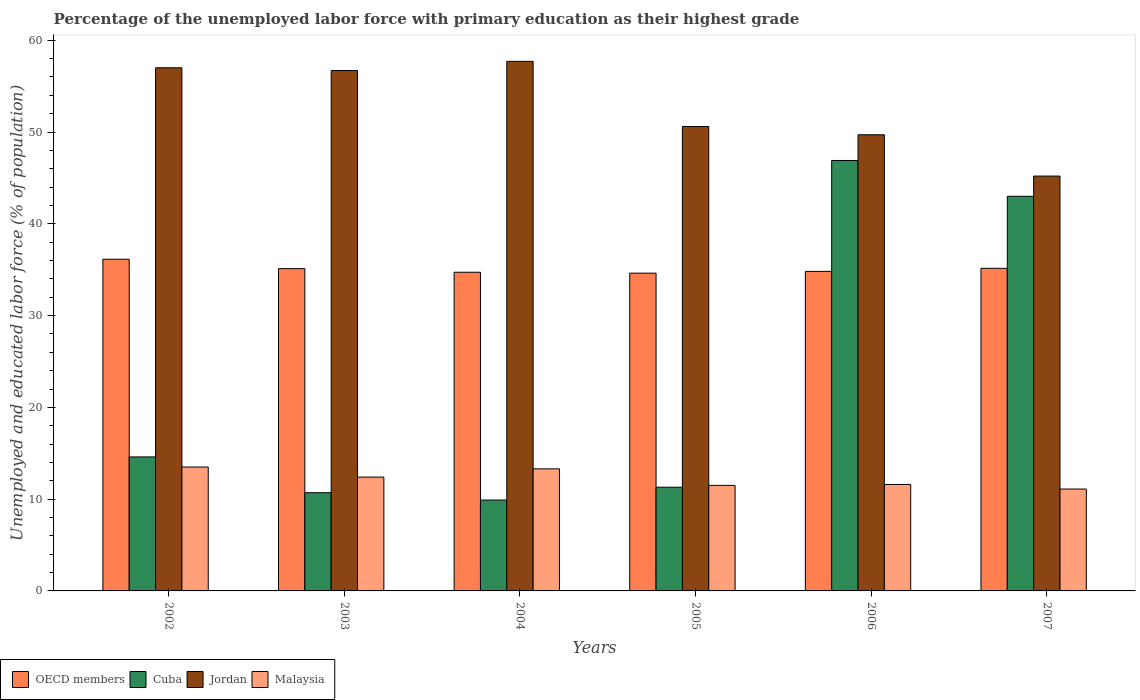How many different coloured bars are there?
Your response must be concise. 4. How many bars are there on the 6th tick from the right?
Make the answer very short. 4. What is the label of the 6th group of bars from the left?
Your answer should be very brief. 2007. What is the percentage of the unemployed labor force with primary education in Malaysia in 2006?
Your response must be concise. 11.6. Across all years, what is the maximum percentage of the unemployed labor force with primary education in OECD members?
Offer a terse response. 36.14. Across all years, what is the minimum percentage of the unemployed labor force with primary education in Jordan?
Ensure brevity in your answer.  45.2. In which year was the percentage of the unemployed labor force with primary education in Malaysia maximum?
Your answer should be very brief. 2002. What is the total percentage of the unemployed labor force with primary education in OECD members in the graph?
Offer a terse response. 210.56. What is the difference between the percentage of the unemployed labor force with primary education in Jordan in 2002 and that in 2003?
Keep it short and to the point. 0.3. What is the difference between the percentage of the unemployed labor force with primary education in Malaysia in 2007 and the percentage of the unemployed labor force with primary education in Jordan in 2004?
Provide a succinct answer. -46.6. What is the average percentage of the unemployed labor force with primary education in Malaysia per year?
Your answer should be very brief. 12.23. In the year 2003, what is the difference between the percentage of the unemployed labor force with primary education in OECD members and percentage of the unemployed labor force with primary education in Cuba?
Ensure brevity in your answer.  24.41. In how many years, is the percentage of the unemployed labor force with primary education in Cuba greater than 42 %?
Your answer should be very brief. 2. What is the ratio of the percentage of the unemployed labor force with primary education in OECD members in 2004 to that in 2007?
Keep it short and to the point. 0.99. Is the percentage of the unemployed labor force with primary education in OECD members in 2004 less than that in 2007?
Your response must be concise. Yes. Is the difference between the percentage of the unemployed labor force with primary education in OECD members in 2003 and 2005 greater than the difference between the percentage of the unemployed labor force with primary education in Cuba in 2003 and 2005?
Your response must be concise. Yes. What is the difference between the highest and the second highest percentage of the unemployed labor force with primary education in OECD members?
Offer a very short reply. 0.99. What is the difference between the highest and the lowest percentage of the unemployed labor force with primary education in Jordan?
Your response must be concise. 12.5. In how many years, is the percentage of the unemployed labor force with primary education in Jordan greater than the average percentage of the unemployed labor force with primary education in Jordan taken over all years?
Provide a succinct answer. 3. Is the sum of the percentage of the unemployed labor force with primary education in OECD members in 2002 and 2003 greater than the maximum percentage of the unemployed labor force with primary education in Jordan across all years?
Make the answer very short. Yes. Is it the case that in every year, the sum of the percentage of the unemployed labor force with primary education in Jordan and percentage of the unemployed labor force with primary education in Cuba is greater than the sum of percentage of the unemployed labor force with primary education in Malaysia and percentage of the unemployed labor force with primary education in OECD members?
Provide a succinct answer. Yes. What does the 1st bar from the right in 2005 represents?
Make the answer very short. Malaysia. Is it the case that in every year, the sum of the percentage of the unemployed labor force with primary education in Cuba and percentage of the unemployed labor force with primary education in Malaysia is greater than the percentage of the unemployed labor force with primary education in OECD members?
Your response must be concise. No. How many bars are there?
Your response must be concise. 24. Are all the bars in the graph horizontal?
Provide a short and direct response. No. What is the difference between two consecutive major ticks on the Y-axis?
Your answer should be compact. 10. Does the graph contain grids?
Offer a very short reply. No. What is the title of the graph?
Offer a very short reply. Percentage of the unemployed labor force with primary education as their highest grade. Does "Malaysia" appear as one of the legend labels in the graph?
Provide a succinct answer. Yes. What is the label or title of the Y-axis?
Make the answer very short. Unemployed and educated labor force (% of population). What is the Unemployed and educated labor force (% of population) of OECD members in 2002?
Give a very brief answer. 36.14. What is the Unemployed and educated labor force (% of population) in Cuba in 2002?
Provide a succinct answer. 14.6. What is the Unemployed and educated labor force (% of population) of Jordan in 2002?
Ensure brevity in your answer.  57. What is the Unemployed and educated labor force (% of population) in OECD members in 2003?
Your answer should be compact. 35.11. What is the Unemployed and educated labor force (% of population) of Cuba in 2003?
Your response must be concise. 10.7. What is the Unemployed and educated labor force (% of population) of Jordan in 2003?
Ensure brevity in your answer.  56.7. What is the Unemployed and educated labor force (% of population) in Malaysia in 2003?
Offer a terse response. 12.4. What is the Unemployed and educated labor force (% of population) in OECD members in 2004?
Give a very brief answer. 34.72. What is the Unemployed and educated labor force (% of population) in Cuba in 2004?
Ensure brevity in your answer.  9.9. What is the Unemployed and educated labor force (% of population) of Jordan in 2004?
Keep it short and to the point. 57.7. What is the Unemployed and educated labor force (% of population) in Malaysia in 2004?
Your answer should be very brief. 13.3. What is the Unemployed and educated labor force (% of population) of OECD members in 2005?
Your response must be concise. 34.62. What is the Unemployed and educated labor force (% of population) of Cuba in 2005?
Provide a short and direct response. 11.3. What is the Unemployed and educated labor force (% of population) of Jordan in 2005?
Make the answer very short. 50.6. What is the Unemployed and educated labor force (% of population) in Malaysia in 2005?
Provide a short and direct response. 11.5. What is the Unemployed and educated labor force (% of population) of OECD members in 2006?
Provide a short and direct response. 34.81. What is the Unemployed and educated labor force (% of population) in Cuba in 2006?
Ensure brevity in your answer.  46.9. What is the Unemployed and educated labor force (% of population) in Jordan in 2006?
Your answer should be compact. 49.7. What is the Unemployed and educated labor force (% of population) in Malaysia in 2006?
Your response must be concise. 11.6. What is the Unemployed and educated labor force (% of population) of OECD members in 2007?
Keep it short and to the point. 35.15. What is the Unemployed and educated labor force (% of population) of Cuba in 2007?
Offer a very short reply. 43. What is the Unemployed and educated labor force (% of population) in Jordan in 2007?
Offer a terse response. 45.2. What is the Unemployed and educated labor force (% of population) in Malaysia in 2007?
Your response must be concise. 11.1. Across all years, what is the maximum Unemployed and educated labor force (% of population) in OECD members?
Your answer should be very brief. 36.14. Across all years, what is the maximum Unemployed and educated labor force (% of population) of Cuba?
Ensure brevity in your answer.  46.9. Across all years, what is the maximum Unemployed and educated labor force (% of population) of Jordan?
Your response must be concise. 57.7. Across all years, what is the minimum Unemployed and educated labor force (% of population) of OECD members?
Offer a terse response. 34.62. Across all years, what is the minimum Unemployed and educated labor force (% of population) of Cuba?
Offer a very short reply. 9.9. Across all years, what is the minimum Unemployed and educated labor force (% of population) in Jordan?
Give a very brief answer. 45.2. Across all years, what is the minimum Unemployed and educated labor force (% of population) of Malaysia?
Give a very brief answer. 11.1. What is the total Unemployed and educated labor force (% of population) of OECD members in the graph?
Offer a very short reply. 210.56. What is the total Unemployed and educated labor force (% of population) in Cuba in the graph?
Ensure brevity in your answer.  136.4. What is the total Unemployed and educated labor force (% of population) of Jordan in the graph?
Ensure brevity in your answer.  316.9. What is the total Unemployed and educated labor force (% of population) of Malaysia in the graph?
Ensure brevity in your answer.  73.4. What is the difference between the Unemployed and educated labor force (% of population) in OECD members in 2002 and that in 2003?
Give a very brief answer. 1.03. What is the difference between the Unemployed and educated labor force (% of population) in Jordan in 2002 and that in 2003?
Keep it short and to the point. 0.3. What is the difference between the Unemployed and educated labor force (% of population) in Malaysia in 2002 and that in 2003?
Your answer should be compact. 1.1. What is the difference between the Unemployed and educated labor force (% of population) in OECD members in 2002 and that in 2004?
Your response must be concise. 1.42. What is the difference between the Unemployed and educated labor force (% of population) of Cuba in 2002 and that in 2004?
Your answer should be compact. 4.7. What is the difference between the Unemployed and educated labor force (% of population) in OECD members in 2002 and that in 2005?
Provide a short and direct response. 1.52. What is the difference between the Unemployed and educated labor force (% of population) in Cuba in 2002 and that in 2005?
Offer a terse response. 3.3. What is the difference between the Unemployed and educated labor force (% of population) of Jordan in 2002 and that in 2005?
Offer a terse response. 6.4. What is the difference between the Unemployed and educated labor force (% of population) in Malaysia in 2002 and that in 2005?
Ensure brevity in your answer.  2. What is the difference between the Unemployed and educated labor force (% of population) in OECD members in 2002 and that in 2006?
Offer a terse response. 1.33. What is the difference between the Unemployed and educated labor force (% of population) of Cuba in 2002 and that in 2006?
Offer a very short reply. -32.3. What is the difference between the Unemployed and educated labor force (% of population) in OECD members in 2002 and that in 2007?
Your answer should be compact. 0.99. What is the difference between the Unemployed and educated labor force (% of population) in Cuba in 2002 and that in 2007?
Keep it short and to the point. -28.4. What is the difference between the Unemployed and educated labor force (% of population) in OECD members in 2003 and that in 2004?
Keep it short and to the point. 0.39. What is the difference between the Unemployed and educated labor force (% of population) in Jordan in 2003 and that in 2004?
Keep it short and to the point. -1. What is the difference between the Unemployed and educated labor force (% of population) of Malaysia in 2003 and that in 2004?
Offer a terse response. -0.9. What is the difference between the Unemployed and educated labor force (% of population) of OECD members in 2003 and that in 2005?
Provide a short and direct response. 0.49. What is the difference between the Unemployed and educated labor force (% of population) in Jordan in 2003 and that in 2005?
Ensure brevity in your answer.  6.1. What is the difference between the Unemployed and educated labor force (% of population) of OECD members in 2003 and that in 2006?
Your response must be concise. 0.3. What is the difference between the Unemployed and educated labor force (% of population) in Cuba in 2003 and that in 2006?
Ensure brevity in your answer.  -36.2. What is the difference between the Unemployed and educated labor force (% of population) of Jordan in 2003 and that in 2006?
Your answer should be compact. 7. What is the difference between the Unemployed and educated labor force (% of population) of Malaysia in 2003 and that in 2006?
Offer a very short reply. 0.8. What is the difference between the Unemployed and educated labor force (% of population) in OECD members in 2003 and that in 2007?
Make the answer very short. -0.04. What is the difference between the Unemployed and educated labor force (% of population) in Cuba in 2003 and that in 2007?
Provide a short and direct response. -32.3. What is the difference between the Unemployed and educated labor force (% of population) of Jordan in 2003 and that in 2007?
Keep it short and to the point. 11.5. What is the difference between the Unemployed and educated labor force (% of population) of Malaysia in 2003 and that in 2007?
Keep it short and to the point. 1.3. What is the difference between the Unemployed and educated labor force (% of population) in OECD members in 2004 and that in 2005?
Your answer should be compact. 0.1. What is the difference between the Unemployed and educated labor force (% of population) of Jordan in 2004 and that in 2005?
Make the answer very short. 7.1. What is the difference between the Unemployed and educated labor force (% of population) of OECD members in 2004 and that in 2006?
Your answer should be compact. -0.09. What is the difference between the Unemployed and educated labor force (% of population) of Cuba in 2004 and that in 2006?
Your answer should be very brief. -37. What is the difference between the Unemployed and educated labor force (% of population) in Malaysia in 2004 and that in 2006?
Make the answer very short. 1.7. What is the difference between the Unemployed and educated labor force (% of population) of OECD members in 2004 and that in 2007?
Offer a very short reply. -0.43. What is the difference between the Unemployed and educated labor force (% of population) of Cuba in 2004 and that in 2007?
Offer a very short reply. -33.1. What is the difference between the Unemployed and educated labor force (% of population) in Jordan in 2004 and that in 2007?
Ensure brevity in your answer.  12.5. What is the difference between the Unemployed and educated labor force (% of population) in OECD members in 2005 and that in 2006?
Offer a very short reply. -0.19. What is the difference between the Unemployed and educated labor force (% of population) of Cuba in 2005 and that in 2006?
Ensure brevity in your answer.  -35.6. What is the difference between the Unemployed and educated labor force (% of population) in Jordan in 2005 and that in 2006?
Provide a succinct answer. 0.9. What is the difference between the Unemployed and educated labor force (% of population) of OECD members in 2005 and that in 2007?
Provide a succinct answer. -0.53. What is the difference between the Unemployed and educated labor force (% of population) in Cuba in 2005 and that in 2007?
Give a very brief answer. -31.7. What is the difference between the Unemployed and educated labor force (% of population) in Malaysia in 2005 and that in 2007?
Ensure brevity in your answer.  0.4. What is the difference between the Unemployed and educated labor force (% of population) of OECD members in 2006 and that in 2007?
Your response must be concise. -0.34. What is the difference between the Unemployed and educated labor force (% of population) of Cuba in 2006 and that in 2007?
Offer a terse response. 3.9. What is the difference between the Unemployed and educated labor force (% of population) of OECD members in 2002 and the Unemployed and educated labor force (% of population) of Cuba in 2003?
Provide a succinct answer. 25.44. What is the difference between the Unemployed and educated labor force (% of population) in OECD members in 2002 and the Unemployed and educated labor force (% of population) in Jordan in 2003?
Ensure brevity in your answer.  -20.56. What is the difference between the Unemployed and educated labor force (% of population) in OECD members in 2002 and the Unemployed and educated labor force (% of population) in Malaysia in 2003?
Make the answer very short. 23.74. What is the difference between the Unemployed and educated labor force (% of population) of Cuba in 2002 and the Unemployed and educated labor force (% of population) of Jordan in 2003?
Your response must be concise. -42.1. What is the difference between the Unemployed and educated labor force (% of population) in Jordan in 2002 and the Unemployed and educated labor force (% of population) in Malaysia in 2003?
Keep it short and to the point. 44.6. What is the difference between the Unemployed and educated labor force (% of population) in OECD members in 2002 and the Unemployed and educated labor force (% of population) in Cuba in 2004?
Ensure brevity in your answer.  26.24. What is the difference between the Unemployed and educated labor force (% of population) in OECD members in 2002 and the Unemployed and educated labor force (% of population) in Jordan in 2004?
Ensure brevity in your answer.  -21.56. What is the difference between the Unemployed and educated labor force (% of population) in OECD members in 2002 and the Unemployed and educated labor force (% of population) in Malaysia in 2004?
Provide a short and direct response. 22.84. What is the difference between the Unemployed and educated labor force (% of population) in Cuba in 2002 and the Unemployed and educated labor force (% of population) in Jordan in 2004?
Offer a very short reply. -43.1. What is the difference between the Unemployed and educated labor force (% of population) of Jordan in 2002 and the Unemployed and educated labor force (% of population) of Malaysia in 2004?
Offer a very short reply. 43.7. What is the difference between the Unemployed and educated labor force (% of population) of OECD members in 2002 and the Unemployed and educated labor force (% of population) of Cuba in 2005?
Offer a very short reply. 24.84. What is the difference between the Unemployed and educated labor force (% of population) in OECD members in 2002 and the Unemployed and educated labor force (% of population) in Jordan in 2005?
Provide a short and direct response. -14.46. What is the difference between the Unemployed and educated labor force (% of population) of OECD members in 2002 and the Unemployed and educated labor force (% of population) of Malaysia in 2005?
Give a very brief answer. 24.64. What is the difference between the Unemployed and educated labor force (% of population) in Cuba in 2002 and the Unemployed and educated labor force (% of population) in Jordan in 2005?
Your response must be concise. -36. What is the difference between the Unemployed and educated labor force (% of population) in Jordan in 2002 and the Unemployed and educated labor force (% of population) in Malaysia in 2005?
Ensure brevity in your answer.  45.5. What is the difference between the Unemployed and educated labor force (% of population) in OECD members in 2002 and the Unemployed and educated labor force (% of population) in Cuba in 2006?
Keep it short and to the point. -10.76. What is the difference between the Unemployed and educated labor force (% of population) of OECD members in 2002 and the Unemployed and educated labor force (% of population) of Jordan in 2006?
Your response must be concise. -13.56. What is the difference between the Unemployed and educated labor force (% of population) of OECD members in 2002 and the Unemployed and educated labor force (% of population) of Malaysia in 2006?
Make the answer very short. 24.54. What is the difference between the Unemployed and educated labor force (% of population) of Cuba in 2002 and the Unemployed and educated labor force (% of population) of Jordan in 2006?
Ensure brevity in your answer.  -35.1. What is the difference between the Unemployed and educated labor force (% of population) of Jordan in 2002 and the Unemployed and educated labor force (% of population) of Malaysia in 2006?
Ensure brevity in your answer.  45.4. What is the difference between the Unemployed and educated labor force (% of population) in OECD members in 2002 and the Unemployed and educated labor force (% of population) in Cuba in 2007?
Your answer should be compact. -6.86. What is the difference between the Unemployed and educated labor force (% of population) of OECD members in 2002 and the Unemployed and educated labor force (% of population) of Jordan in 2007?
Provide a succinct answer. -9.06. What is the difference between the Unemployed and educated labor force (% of population) of OECD members in 2002 and the Unemployed and educated labor force (% of population) of Malaysia in 2007?
Offer a terse response. 25.04. What is the difference between the Unemployed and educated labor force (% of population) of Cuba in 2002 and the Unemployed and educated labor force (% of population) of Jordan in 2007?
Offer a very short reply. -30.6. What is the difference between the Unemployed and educated labor force (% of population) in Cuba in 2002 and the Unemployed and educated labor force (% of population) in Malaysia in 2007?
Your response must be concise. 3.5. What is the difference between the Unemployed and educated labor force (% of population) in Jordan in 2002 and the Unemployed and educated labor force (% of population) in Malaysia in 2007?
Keep it short and to the point. 45.9. What is the difference between the Unemployed and educated labor force (% of population) of OECD members in 2003 and the Unemployed and educated labor force (% of population) of Cuba in 2004?
Your answer should be compact. 25.21. What is the difference between the Unemployed and educated labor force (% of population) in OECD members in 2003 and the Unemployed and educated labor force (% of population) in Jordan in 2004?
Your response must be concise. -22.59. What is the difference between the Unemployed and educated labor force (% of population) of OECD members in 2003 and the Unemployed and educated labor force (% of population) of Malaysia in 2004?
Offer a very short reply. 21.81. What is the difference between the Unemployed and educated labor force (% of population) in Cuba in 2003 and the Unemployed and educated labor force (% of population) in Jordan in 2004?
Ensure brevity in your answer.  -47. What is the difference between the Unemployed and educated labor force (% of population) in Jordan in 2003 and the Unemployed and educated labor force (% of population) in Malaysia in 2004?
Your response must be concise. 43.4. What is the difference between the Unemployed and educated labor force (% of population) in OECD members in 2003 and the Unemployed and educated labor force (% of population) in Cuba in 2005?
Make the answer very short. 23.81. What is the difference between the Unemployed and educated labor force (% of population) in OECD members in 2003 and the Unemployed and educated labor force (% of population) in Jordan in 2005?
Provide a succinct answer. -15.49. What is the difference between the Unemployed and educated labor force (% of population) in OECD members in 2003 and the Unemployed and educated labor force (% of population) in Malaysia in 2005?
Your answer should be very brief. 23.61. What is the difference between the Unemployed and educated labor force (% of population) in Cuba in 2003 and the Unemployed and educated labor force (% of population) in Jordan in 2005?
Ensure brevity in your answer.  -39.9. What is the difference between the Unemployed and educated labor force (% of population) of Jordan in 2003 and the Unemployed and educated labor force (% of population) of Malaysia in 2005?
Give a very brief answer. 45.2. What is the difference between the Unemployed and educated labor force (% of population) of OECD members in 2003 and the Unemployed and educated labor force (% of population) of Cuba in 2006?
Give a very brief answer. -11.79. What is the difference between the Unemployed and educated labor force (% of population) in OECD members in 2003 and the Unemployed and educated labor force (% of population) in Jordan in 2006?
Provide a succinct answer. -14.59. What is the difference between the Unemployed and educated labor force (% of population) in OECD members in 2003 and the Unemployed and educated labor force (% of population) in Malaysia in 2006?
Keep it short and to the point. 23.51. What is the difference between the Unemployed and educated labor force (% of population) in Cuba in 2003 and the Unemployed and educated labor force (% of population) in Jordan in 2006?
Offer a very short reply. -39. What is the difference between the Unemployed and educated labor force (% of population) in Cuba in 2003 and the Unemployed and educated labor force (% of population) in Malaysia in 2006?
Keep it short and to the point. -0.9. What is the difference between the Unemployed and educated labor force (% of population) in Jordan in 2003 and the Unemployed and educated labor force (% of population) in Malaysia in 2006?
Ensure brevity in your answer.  45.1. What is the difference between the Unemployed and educated labor force (% of population) of OECD members in 2003 and the Unemployed and educated labor force (% of population) of Cuba in 2007?
Ensure brevity in your answer.  -7.89. What is the difference between the Unemployed and educated labor force (% of population) in OECD members in 2003 and the Unemployed and educated labor force (% of population) in Jordan in 2007?
Your answer should be very brief. -10.09. What is the difference between the Unemployed and educated labor force (% of population) of OECD members in 2003 and the Unemployed and educated labor force (% of population) of Malaysia in 2007?
Ensure brevity in your answer.  24.01. What is the difference between the Unemployed and educated labor force (% of population) in Cuba in 2003 and the Unemployed and educated labor force (% of population) in Jordan in 2007?
Your response must be concise. -34.5. What is the difference between the Unemployed and educated labor force (% of population) of Jordan in 2003 and the Unemployed and educated labor force (% of population) of Malaysia in 2007?
Keep it short and to the point. 45.6. What is the difference between the Unemployed and educated labor force (% of population) of OECD members in 2004 and the Unemployed and educated labor force (% of population) of Cuba in 2005?
Make the answer very short. 23.42. What is the difference between the Unemployed and educated labor force (% of population) of OECD members in 2004 and the Unemployed and educated labor force (% of population) of Jordan in 2005?
Offer a very short reply. -15.88. What is the difference between the Unemployed and educated labor force (% of population) of OECD members in 2004 and the Unemployed and educated labor force (% of population) of Malaysia in 2005?
Your answer should be compact. 23.22. What is the difference between the Unemployed and educated labor force (% of population) in Cuba in 2004 and the Unemployed and educated labor force (% of population) in Jordan in 2005?
Make the answer very short. -40.7. What is the difference between the Unemployed and educated labor force (% of population) in Jordan in 2004 and the Unemployed and educated labor force (% of population) in Malaysia in 2005?
Offer a terse response. 46.2. What is the difference between the Unemployed and educated labor force (% of population) of OECD members in 2004 and the Unemployed and educated labor force (% of population) of Cuba in 2006?
Ensure brevity in your answer.  -12.18. What is the difference between the Unemployed and educated labor force (% of population) of OECD members in 2004 and the Unemployed and educated labor force (% of population) of Jordan in 2006?
Your answer should be very brief. -14.98. What is the difference between the Unemployed and educated labor force (% of population) of OECD members in 2004 and the Unemployed and educated labor force (% of population) of Malaysia in 2006?
Provide a short and direct response. 23.12. What is the difference between the Unemployed and educated labor force (% of population) in Cuba in 2004 and the Unemployed and educated labor force (% of population) in Jordan in 2006?
Your answer should be compact. -39.8. What is the difference between the Unemployed and educated labor force (% of population) in Cuba in 2004 and the Unemployed and educated labor force (% of population) in Malaysia in 2006?
Make the answer very short. -1.7. What is the difference between the Unemployed and educated labor force (% of population) in Jordan in 2004 and the Unemployed and educated labor force (% of population) in Malaysia in 2006?
Your answer should be very brief. 46.1. What is the difference between the Unemployed and educated labor force (% of population) of OECD members in 2004 and the Unemployed and educated labor force (% of population) of Cuba in 2007?
Offer a terse response. -8.28. What is the difference between the Unemployed and educated labor force (% of population) of OECD members in 2004 and the Unemployed and educated labor force (% of population) of Jordan in 2007?
Ensure brevity in your answer.  -10.48. What is the difference between the Unemployed and educated labor force (% of population) in OECD members in 2004 and the Unemployed and educated labor force (% of population) in Malaysia in 2007?
Your response must be concise. 23.62. What is the difference between the Unemployed and educated labor force (% of population) in Cuba in 2004 and the Unemployed and educated labor force (% of population) in Jordan in 2007?
Ensure brevity in your answer.  -35.3. What is the difference between the Unemployed and educated labor force (% of population) in Cuba in 2004 and the Unemployed and educated labor force (% of population) in Malaysia in 2007?
Offer a very short reply. -1.2. What is the difference between the Unemployed and educated labor force (% of population) in Jordan in 2004 and the Unemployed and educated labor force (% of population) in Malaysia in 2007?
Provide a succinct answer. 46.6. What is the difference between the Unemployed and educated labor force (% of population) of OECD members in 2005 and the Unemployed and educated labor force (% of population) of Cuba in 2006?
Keep it short and to the point. -12.28. What is the difference between the Unemployed and educated labor force (% of population) of OECD members in 2005 and the Unemployed and educated labor force (% of population) of Jordan in 2006?
Ensure brevity in your answer.  -15.08. What is the difference between the Unemployed and educated labor force (% of population) in OECD members in 2005 and the Unemployed and educated labor force (% of population) in Malaysia in 2006?
Your answer should be very brief. 23.02. What is the difference between the Unemployed and educated labor force (% of population) of Cuba in 2005 and the Unemployed and educated labor force (% of population) of Jordan in 2006?
Your answer should be very brief. -38.4. What is the difference between the Unemployed and educated labor force (% of population) in Jordan in 2005 and the Unemployed and educated labor force (% of population) in Malaysia in 2006?
Your response must be concise. 39. What is the difference between the Unemployed and educated labor force (% of population) of OECD members in 2005 and the Unemployed and educated labor force (% of population) of Cuba in 2007?
Provide a succinct answer. -8.38. What is the difference between the Unemployed and educated labor force (% of population) of OECD members in 2005 and the Unemployed and educated labor force (% of population) of Jordan in 2007?
Keep it short and to the point. -10.58. What is the difference between the Unemployed and educated labor force (% of population) of OECD members in 2005 and the Unemployed and educated labor force (% of population) of Malaysia in 2007?
Provide a succinct answer. 23.52. What is the difference between the Unemployed and educated labor force (% of population) of Cuba in 2005 and the Unemployed and educated labor force (% of population) of Jordan in 2007?
Offer a terse response. -33.9. What is the difference between the Unemployed and educated labor force (% of population) of Jordan in 2005 and the Unemployed and educated labor force (% of population) of Malaysia in 2007?
Your answer should be compact. 39.5. What is the difference between the Unemployed and educated labor force (% of population) of OECD members in 2006 and the Unemployed and educated labor force (% of population) of Cuba in 2007?
Offer a terse response. -8.19. What is the difference between the Unemployed and educated labor force (% of population) of OECD members in 2006 and the Unemployed and educated labor force (% of population) of Jordan in 2007?
Your answer should be compact. -10.39. What is the difference between the Unemployed and educated labor force (% of population) of OECD members in 2006 and the Unemployed and educated labor force (% of population) of Malaysia in 2007?
Your answer should be very brief. 23.71. What is the difference between the Unemployed and educated labor force (% of population) in Cuba in 2006 and the Unemployed and educated labor force (% of population) in Malaysia in 2007?
Provide a short and direct response. 35.8. What is the difference between the Unemployed and educated labor force (% of population) of Jordan in 2006 and the Unemployed and educated labor force (% of population) of Malaysia in 2007?
Your answer should be compact. 38.6. What is the average Unemployed and educated labor force (% of population) in OECD members per year?
Your answer should be compact. 35.09. What is the average Unemployed and educated labor force (% of population) in Cuba per year?
Ensure brevity in your answer.  22.73. What is the average Unemployed and educated labor force (% of population) of Jordan per year?
Offer a terse response. 52.82. What is the average Unemployed and educated labor force (% of population) of Malaysia per year?
Provide a short and direct response. 12.23. In the year 2002, what is the difference between the Unemployed and educated labor force (% of population) in OECD members and Unemployed and educated labor force (% of population) in Cuba?
Ensure brevity in your answer.  21.54. In the year 2002, what is the difference between the Unemployed and educated labor force (% of population) in OECD members and Unemployed and educated labor force (% of population) in Jordan?
Your answer should be very brief. -20.86. In the year 2002, what is the difference between the Unemployed and educated labor force (% of population) in OECD members and Unemployed and educated labor force (% of population) in Malaysia?
Ensure brevity in your answer.  22.64. In the year 2002, what is the difference between the Unemployed and educated labor force (% of population) in Cuba and Unemployed and educated labor force (% of population) in Jordan?
Keep it short and to the point. -42.4. In the year 2002, what is the difference between the Unemployed and educated labor force (% of population) of Cuba and Unemployed and educated labor force (% of population) of Malaysia?
Keep it short and to the point. 1.1. In the year 2002, what is the difference between the Unemployed and educated labor force (% of population) in Jordan and Unemployed and educated labor force (% of population) in Malaysia?
Your answer should be compact. 43.5. In the year 2003, what is the difference between the Unemployed and educated labor force (% of population) in OECD members and Unemployed and educated labor force (% of population) in Cuba?
Provide a short and direct response. 24.41. In the year 2003, what is the difference between the Unemployed and educated labor force (% of population) of OECD members and Unemployed and educated labor force (% of population) of Jordan?
Ensure brevity in your answer.  -21.59. In the year 2003, what is the difference between the Unemployed and educated labor force (% of population) of OECD members and Unemployed and educated labor force (% of population) of Malaysia?
Ensure brevity in your answer.  22.71. In the year 2003, what is the difference between the Unemployed and educated labor force (% of population) of Cuba and Unemployed and educated labor force (% of population) of Jordan?
Your response must be concise. -46. In the year 2003, what is the difference between the Unemployed and educated labor force (% of population) of Cuba and Unemployed and educated labor force (% of population) of Malaysia?
Offer a terse response. -1.7. In the year 2003, what is the difference between the Unemployed and educated labor force (% of population) of Jordan and Unemployed and educated labor force (% of population) of Malaysia?
Your answer should be compact. 44.3. In the year 2004, what is the difference between the Unemployed and educated labor force (% of population) in OECD members and Unemployed and educated labor force (% of population) in Cuba?
Your answer should be very brief. 24.82. In the year 2004, what is the difference between the Unemployed and educated labor force (% of population) of OECD members and Unemployed and educated labor force (% of population) of Jordan?
Your answer should be compact. -22.98. In the year 2004, what is the difference between the Unemployed and educated labor force (% of population) in OECD members and Unemployed and educated labor force (% of population) in Malaysia?
Give a very brief answer. 21.42. In the year 2004, what is the difference between the Unemployed and educated labor force (% of population) of Cuba and Unemployed and educated labor force (% of population) of Jordan?
Keep it short and to the point. -47.8. In the year 2004, what is the difference between the Unemployed and educated labor force (% of population) of Jordan and Unemployed and educated labor force (% of population) of Malaysia?
Ensure brevity in your answer.  44.4. In the year 2005, what is the difference between the Unemployed and educated labor force (% of population) in OECD members and Unemployed and educated labor force (% of population) in Cuba?
Your answer should be compact. 23.32. In the year 2005, what is the difference between the Unemployed and educated labor force (% of population) of OECD members and Unemployed and educated labor force (% of population) of Jordan?
Provide a succinct answer. -15.98. In the year 2005, what is the difference between the Unemployed and educated labor force (% of population) of OECD members and Unemployed and educated labor force (% of population) of Malaysia?
Offer a very short reply. 23.12. In the year 2005, what is the difference between the Unemployed and educated labor force (% of population) in Cuba and Unemployed and educated labor force (% of population) in Jordan?
Offer a terse response. -39.3. In the year 2005, what is the difference between the Unemployed and educated labor force (% of population) in Jordan and Unemployed and educated labor force (% of population) in Malaysia?
Make the answer very short. 39.1. In the year 2006, what is the difference between the Unemployed and educated labor force (% of population) of OECD members and Unemployed and educated labor force (% of population) of Cuba?
Make the answer very short. -12.09. In the year 2006, what is the difference between the Unemployed and educated labor force (% of population) of OECD members and Unemployed and educated labor force (% of population) of Jordan?
Make the answer very short. -14.89. In the year 2006, what is the difference between the Unemployed and educated labor force (% of population) in OECD members and Unemployed and educated labor force (% of population) in Malaysia?
Make the answer very short. 23.21. In the year 2006, what is the difference between the Unemployed and educated labor force (% of population) of Cuba and Unemployed and educated labor force (% of population) of Malaysia?
Your answer should be compact. 35.3. In the year 2006, what is the difference between the Unemployed and educated labor force (% of population) in Jordan and Unemployed and educated labor force (% of population) in Malaysia?
Offer a very short reply. 38.1. In the year 2007, what is the difference between the Unemployed and educated labor force (% of population) of OECD members and Unemployed and educated labor force (% of population) of Cuba?
Make the answer very short. -7.85. In the year 2007, what is the difference between the Unemployed and educated labor force (% of population) of OECD members and Unemployed and educated labor force (% of population) of Jordan?
Give a very brief answer. -10.05. In the year 2007, what is the difference between the Unemployed and educated labor force (% of population) of OECD members and Unemployed and educated labor force (% of population) of Malaysia?
Your response must be concise. 24.05. In the year 2007, what is the difference between the Unemployed and educated labor force (% of population) in Cuba and Unemployed and educated labor force (% of population) in Malaysia?
Your response must be concise. 31.9. In the year 2007, what is the difference between the Unemployed and educated labor force (% of population) of Jordan and Unemployed and educated labor force (% of population) of Malaysia?
Your answer should be very brief. 34.1. What is the ratio of the Unemployed and educated labor force (% of population) of OECD members in 2002 to that in 2003?
Your response must be concise. 1.03. What is the ratio of the Unemployed and educated labor force (% of population) of Cuba in 2002 to that in 2003?
Your answer should be very brief. 1.36. What is the ratio of the Unemployed and educated labor force (% of population) of Malaysia in 2002 to that in 2003?
Ensure brevity in your answer.  1.09. What is the ratio of the Unemployed and educated labor force (% of population) of OECD members in 2002 to that in 2004?
Offer a terse response. 1.04. What is the ratio of the Unemployed and educated labor force (% of population) of Cuba in 2002 to that in 2004?
Keep it short and to the point. 1.47. What is the ratio of the Unemployed and educated labor force (% of population) of Jordan in 2002 to that in 2004?
Keep it short and to the point. 0.99. What is the ratio of the Unemployed and educated labor force (% of population) of OECD members in 2002 to that in 2005?
Give a very brief answer. 1.04. What is the ratio of the Unemployed and educated labor force (% of population) in Cuba in 2002 to that in 2005?
Keep it short and to the point. 1.29. What is the ratio of the Unemployed and educated labor force (% of population) in Jordan in 2002 to that in 2005?
Your answer should be compact. 1.13. What is the ratio of the Unemployed and educated labor force (% of population) of Malaysia in 2002 to that in 2005?
Offer a very short reply. 1.17. What is the ratio of the Unemployed and educated labor force (% of population) in OECD members in 2002 to that in 2006?
Your response must be concise. 1.04. What is the ratio of the Unemployed and educated labor force (% of population) in Cuba in 2002 to that in 2006?
Your answer should be very brief. 0.31. What is the ratio of the Unemployed and educated labor force (% of population) in Jordan in 2002 to that in 2006?
Ensure brevity in your answer.  1.15. What is the ratio of the Unemployed and educated labor force (% of population) of Malaysia in 2002 to that in 2006?
Provide a short and direct response. 1.16. What is the ratio of the Unemployed and educated labor force (% of population) of OECD members in 2002 to that in 2007?
Provide a short and direct response. 1.03. What is the ratio of the Unemployed and educated labor force (% of population) in Cuba in 2002 to that in 2007?
Give a very brief answer. 0.34. What is the ratio of the Unemployed and educated labor force (% of population) of Jordan in 2002 to that in 2007?
Your answer should be compact. 1.26. What is the ratio of the Unemployed and educated labor force (% of population) in Malaysia in 2002 to that in 2007?
Provide a succinct answer. 1.22. What is the ratio of the Unemployed and educated labor force (% of population) in OECD members in 2003 to that in 2004?
Keep it short and to the point. 1.01. What is the ratio of the Unemployed and educated labor force (% of population) of Cuba in 2003 to that in 2004?
Provide a short and direct response. 1.08. What is the ratio of the Unemployed and educated labor force (% of population) in Jordan in 2003 to that in 2004?
Give a very brief answer. 0.98. What is the ratio of the Unemployed and educated labor force (% of population) of Malaysia in 2003 to that in 2004?
Ensure brevity in your answer.  0.93. What is the ratio of the Unemployed and educated labor force (% of population) of OECD members in 2003 to that in 2005?
Your answer should be very brief. 1.01. What is the ratio of the Unemployed and educated labor force (% of population) in Cuba in 2003 to that in 2005?
Your answer should be very brief. 0.95. What is the ratio of the Unemployed and educated labor force (% of population) of Jordan in 2003 to that in 2005?
Your answer should be compact. 1.12. What is the ratio of the Unemployed and educated labor force (% of population) of Malaysia in 2003 to that in 2005?
Offer a terse response. 1.08. What is the ratio of the Unemployed and educated labor force (% of population) in OECD members in 2003 to that in 2006?
Your response must be concise. 1.01. What is the ratio of the Unemployed and educated labor force (% of population) in Cuba in 2003 to that in 2006?
Provide a short and direct response. 0.23. What is the ratio of the Unemployed and educated labor force (% of population) in Jordan in 2003 to that in 2006?
Your answer should be compact. 1.14. What is the ratio of the Unemployed and educated labor force (% of population) of Malaysia in 2003 to that in 2006?
Offer a terse response. 1.07. What is the ratio of the Unemployed and educated labor force (% of population) of OECD members in 2003 to that in 2007?
Your answer should be very brief. 1. What is the ratio of the Unemployed and educated labor force (% of population) in Cuba in 2003 to that in 2007?
Offer a very short reply. 0.25. What is the ratio of the Unemployed and educated labor force (% of population) in Jordan in 2003 to that in 2007?
Provide a short and direct response. 1.25. What is the ratio of the Unemployed and educated labor force (% of population) of Malaysia in 2003 to that in 2007?
Offer a terse response. 1.12. What is the ratio of the Unemployed and educated labor force (% of population) in OECD members in 2004 to that in 2005?
Provide a succinct answer. 1. What is the ratio of the Unemployed and educated labor force (% of population) of Cuba in 2004 to that in 2005?
Offer a terse response. 0.88. What is the ratio of the Unemployed and educated labor force (% of population) of Jordan in 2004 to that in 2005?
Keep it short and to the point. 1.14. What is the ratio of the Unemployed and educated labor force (% of population) in Malaysia in 2004 to that in 2005?
Offer a very short reply. 1.16. What is the ratio of the Unemployed and educated labor force (% of population) in OECD members in 2004 to that in 2006?
Ensure brevity in your answer.  1. What is the ratio of the Unemployed and educated labor force (% of population) of Cuba in 2004 to that in 2006?
Your answer should be compact. 0.21. What is the ratio of the Unemployed and educated labor force (% of population) of Jordan in 2004 to that in 2006?
Offer a very short reply. 1.16. What is the ratio of the Unemployed and educated labor force (% of population) of Malaysia in 2004 to that in 2006?
Your answer should be very brief. 1.15. What is the ratio of the Unemployed and educated labor force (% of population) in OECD members in 2004 to that in 2007?
Your answer should be compact. 0.99. What is the ratio of the Unemployed and educated labor force (% of population) in Cuba in 2004 to that in 2007?
Your response must be concise. 0.23. What is the ratio of the Unemployed and educated labor force (% of population) in Jordan in 2004 to that in 2007?
Offer a very short reply. 1.28. What is the ratio of the Unemployed and educated labor force (% of population) in Malaysia in 2004 to that in 2007?
Give a very brief answer. 1.2. What is the ratio of the Unemployed and educated labor force (% of population) in OECD members in 2005 to that in 2006?
Offer a terse response. 0.99. What is the ratio of the Unemployed and educated labor force (% of population) in Cuba in 2005 to that in 2006?
Your response must be concise. 0.24. What is the ratio of the Unemployed and educated labor force (% of population) of Jordan in 2005 to that in 2006?
Your answer should be very brief. 1.02. What is the ratio of the Unemployed and educated labor force (% of population) in Malaysia in 2005 to that in 2006?
Ensure brevity in your answer.  0.99. What is the ratio of the Unemployed and educated labor force (% of population) of OECD members in 2005 to that in 2007?
Provide a short and direct response. 0.98. What is the ratio of the Unemployed and educated labor force (% of population) in Cuba in 2005 to that in 2007?
Your answer should be very brief. 0.26. What is the ratio of the Unemployed and educated labor force (% of population) in Jordan in 2005 to that in 2007?
Provide a short and direct response. 1.12. What is the ratio of the Unemployed and educated labor force (% of population) of Malaysia in 2005 to that in 2007?
Provide a short and direct response. 1.04. What is the ratio of the Unemployed and educated labor force (% of population) of OECD members in 2006 to that in 2007?
Offer a terse response. 0.99. What is the ratio of the Unemployed and educated labor force (% of population) in Cuba in 2006 to that in 2007?
Give a very brief answer. 1.09. What is the ratio of the Unemployed and educated labor force (% of population) in Jordan in 2006 to that in 2007?
Provide a short and direct response. 1.1. What is the ratio of the Unemployed and educated labor force (% of population) of Malaysia in 2006 to that in 2007?
Your answer should be very brief. 1.04. What is the difference between the highest and the second highest Unemployed and educated labor force (% of population) of OECD members?
Your answer should be compact. 0.99. What is the difference between the highest and the second highest Unemployed and educated labor force (% of population) of Malaysia?
Your response must be concise. 0.2. What is the difference between the highest and the lowest Unemployed and educated labor force (% of population) in OECD members?
Your answer should be compact. 1.52. What is the difference between the highest and the lowest Unemployed and educated labor force (% of population) in Cuba?
Keep it short and to the point. 37. What is the difference between the highest and the lowest Unemployed and educated labor force (% of population) of Jordan?
Provide a succinct answer. 12.5. What is the difference between the highest and the lowest Unemployed and educated labor force (% of population) in Malaysia?
Offer a terse response. 2.4. 